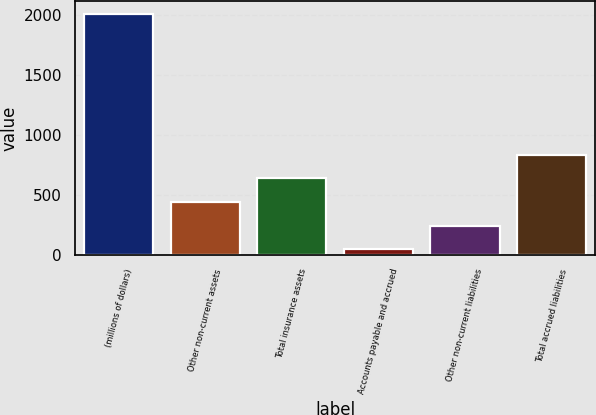Convert chart to OTSL. <chart><loc_0><loc_0><loc_500><loc_500><bar_chart><fcel>(millions of dollars)<fcel>Other non-current assets<fcel>Total insurance assets<fcel>Accounts payable and accrued<fcel>Other non-current liabilities<fcel>Total accrued liabilities<nl><fcel>2014<fcel>440.72<fcel>637.38<fcel>47.4<fcel>244.06<fcel>834.04<nl></chart> 